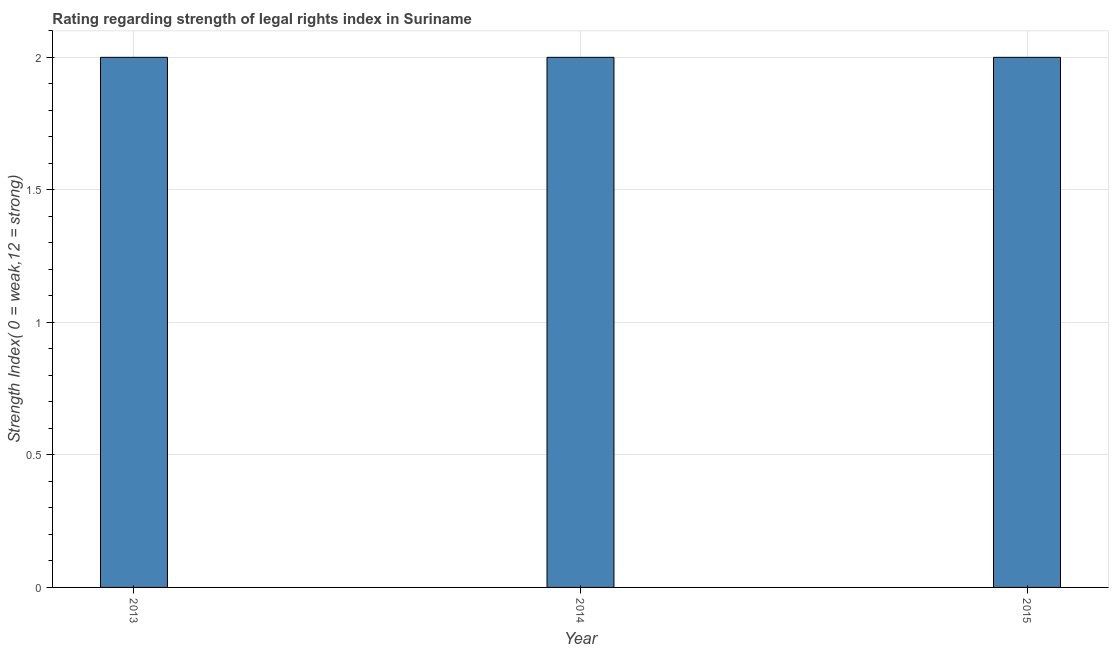Does the graph contain grids?
Your answer should be very brief. Yes. What is the title of the graph?
Your answer should be very brief. Rating regarding strength of legal rights index in Suriname. What is the label or title of the X-axis?
Your answer should be very brief. Year. What is the label or title of the Y-axis?
Your response must be concise. Strength Index( 0 = weak,12 = strong). Across all years, what is the maximum strength of legal rights index?
Your answer should be very brief. 2. Across all years, what is the minimum strength of legal rights index?
Provide a short and direct response. 2. What is the sum of the strength of legal rights index?
Make the answer very short. 6. In how many years, is the strength of legal rights index greater than 2 ?
Give a very brief answer. 0. Is the difference between the strength of legal rights index in 2013 and 2014 greater than the difference between any two years?
Your answer should be compact. Yes. What is the difference between the highest and the second highest strength of legal rights index?
Your answer should be very brief. 0. Is the sum of the strength of legal rights index in 2014 and 2015 greater than the maximum strength of legal rights index across all years?
Your answer should be compact. Yes. How many years are there in the graph?
Provide a short and direct response. 3. Are the values on the major ticks of Y-axis written in scientific E-notation?
Provide a short and direct response. No. What is the difference between the Strength Index( 0 = weak,12 = strong) in 2013 and 2014?
Make the answer very short. 0. What is the difference between the Strength Index( 0 = weak,12 = strong) in 2013 and 2015?
Your response must be concise. 0. What is the ratio of the Strength Index( 0 = weak,12 = strong) in 2013 to that in 2014?
Your response must be concise. 1. What is the ratio of the Strength Index( 0 = weak,12 = strong) in 2013 to that in 2015?
Make the answer very short. 1. What is the ratio of the Strength Index( 0 = weak,12 = strong) in 2014 to that in 2015?
Provide a short and direct response. 1. 